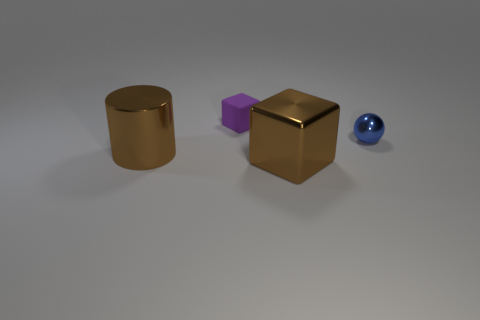Add 2 large gray shiny spheres. How many objects exist? 6 Subtract all cylinders. How many objects are left? 3 Subtract 0 cyan cubes. How many objects are left? 4 Subtract all small matte cubes. Subtract all small matte blocks. How many objects are left? 2 Add 3 metallic cubes. How many metallic cubes are left? 4 Add 3 gray matte cylinders. How many gray matte cylinders exist? 3 